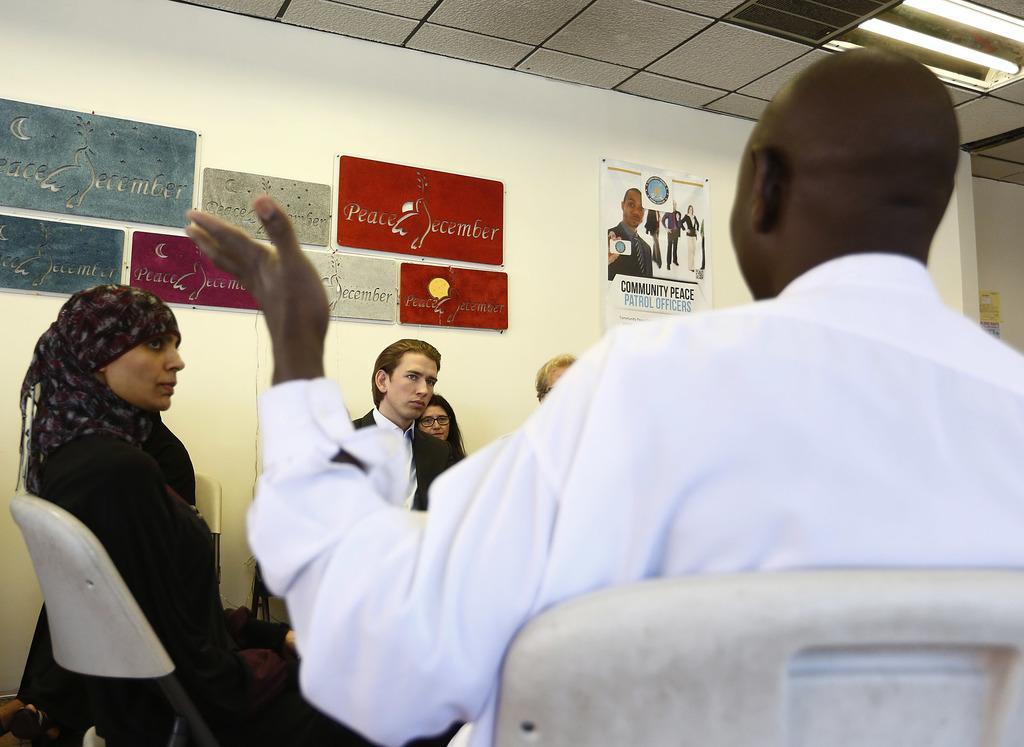Could you give a brief overview of what you see in this image? In this picture we can see some people sitting on chairs, in the background there is a wall, we can see some boards and a paper on the wall, we can see lights and ceiling at the top of the picture. 